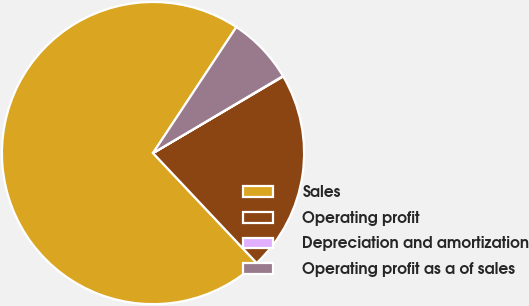Convert chart to OTSL. <chart><loc_0><loc_0><loc_500><loc_500><pie_chart><fcel>Sales<fcel>Operating profit<fcel>Depreciation and amortization<fcel>Operating profit as a of sales<nl><fcel>71.34%<fcel>21.44%<fcel>0.05%<fcel>7.18%<nl></chart> 